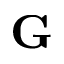Convert formula to latex. <formula><loc_0><loc_0><loc_500><loc_500>G</formula> 